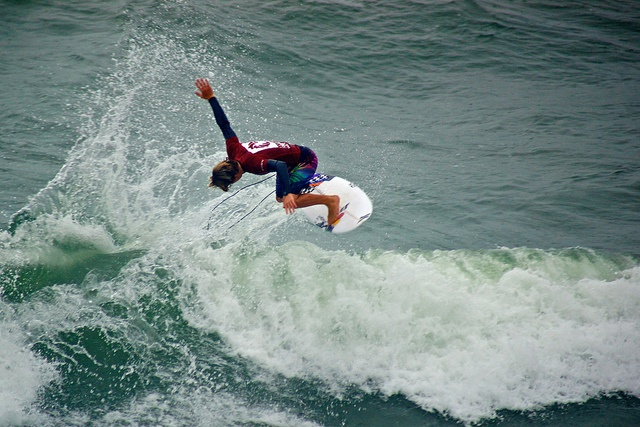Describe the objects in this image and their specific colors. I can see people in teal, black, maroon, darkgray, and navy tones and surfboard in teal, lightgray, darkgray, and gray tones in this image. 